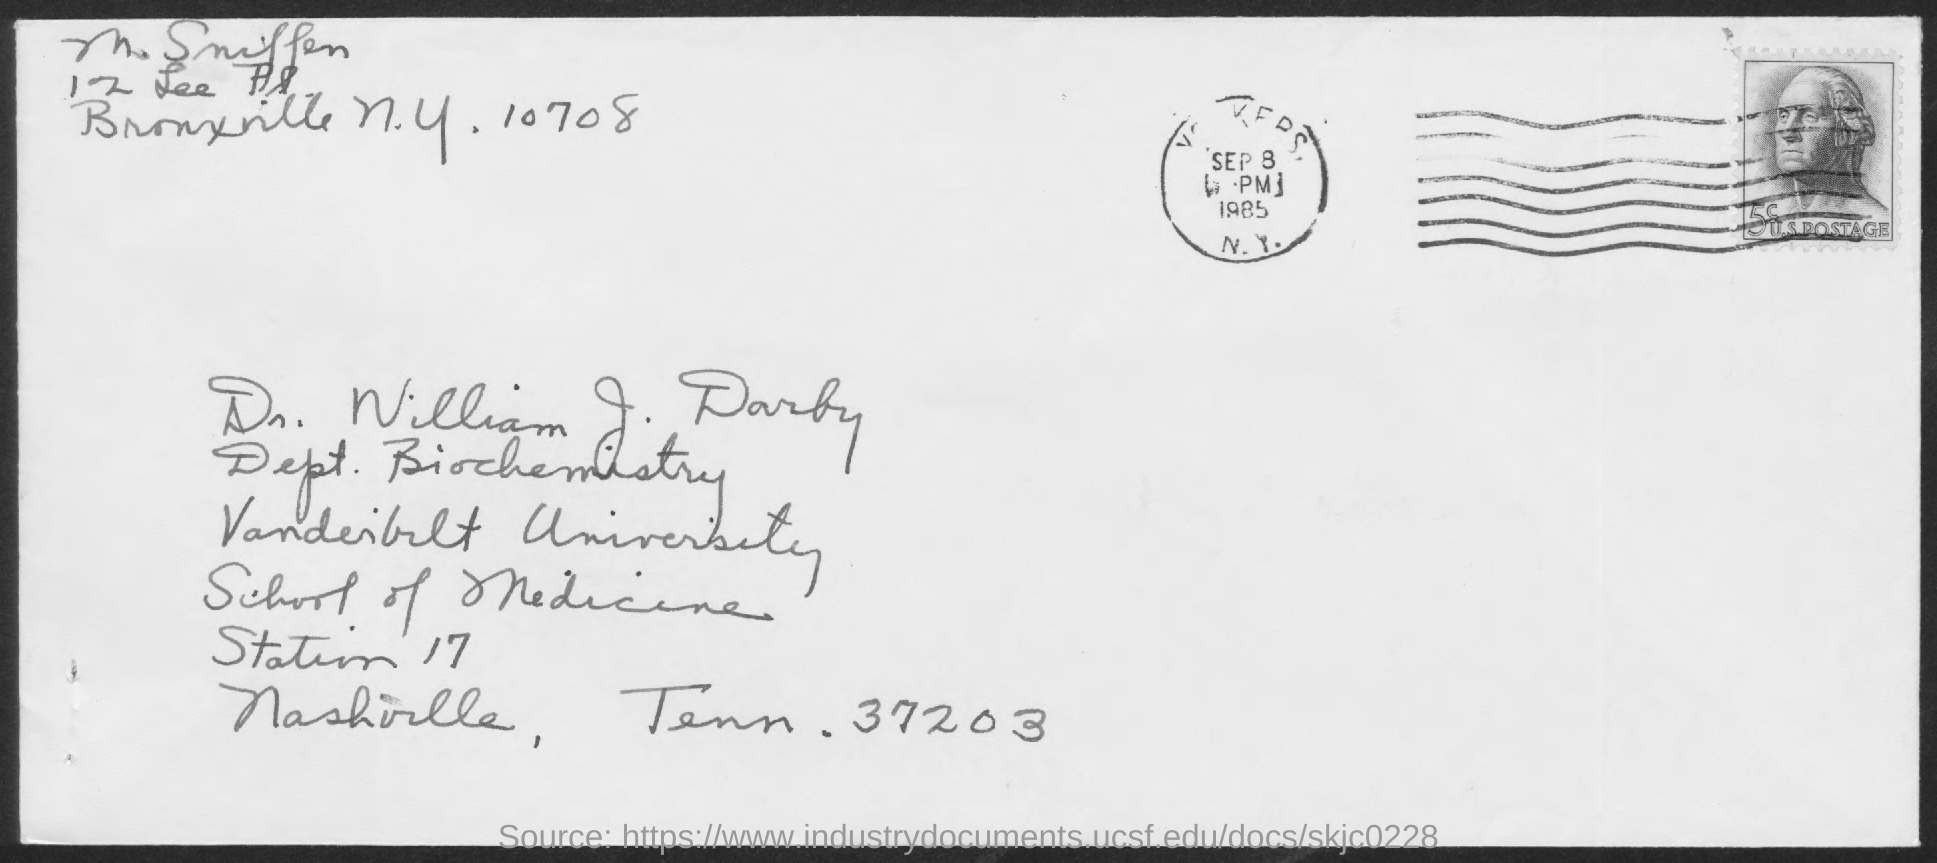Who's from the vanderbilt university as given in the address?
Give a very brief answer. DR. WILLIAM J. DARBY. 